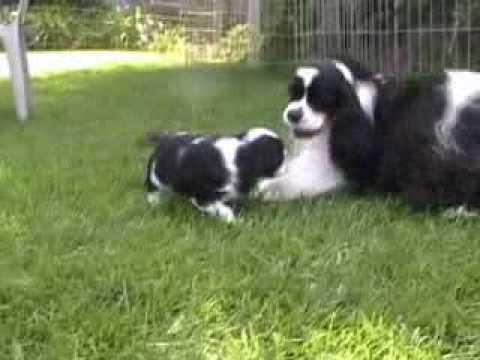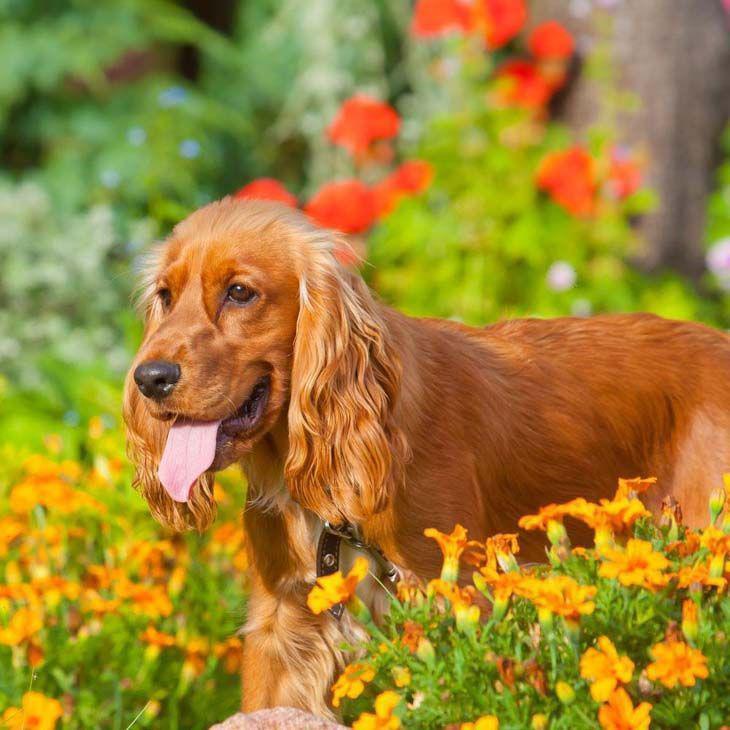The first image is the image on the left, the second image is the image on the right. Examine the images to the left and right. Is the description "Two dogs are playing in the grass in the left image, and the right image includes an orange spaniel with an open mouth." accurate? Answer yes or no. Yes. 